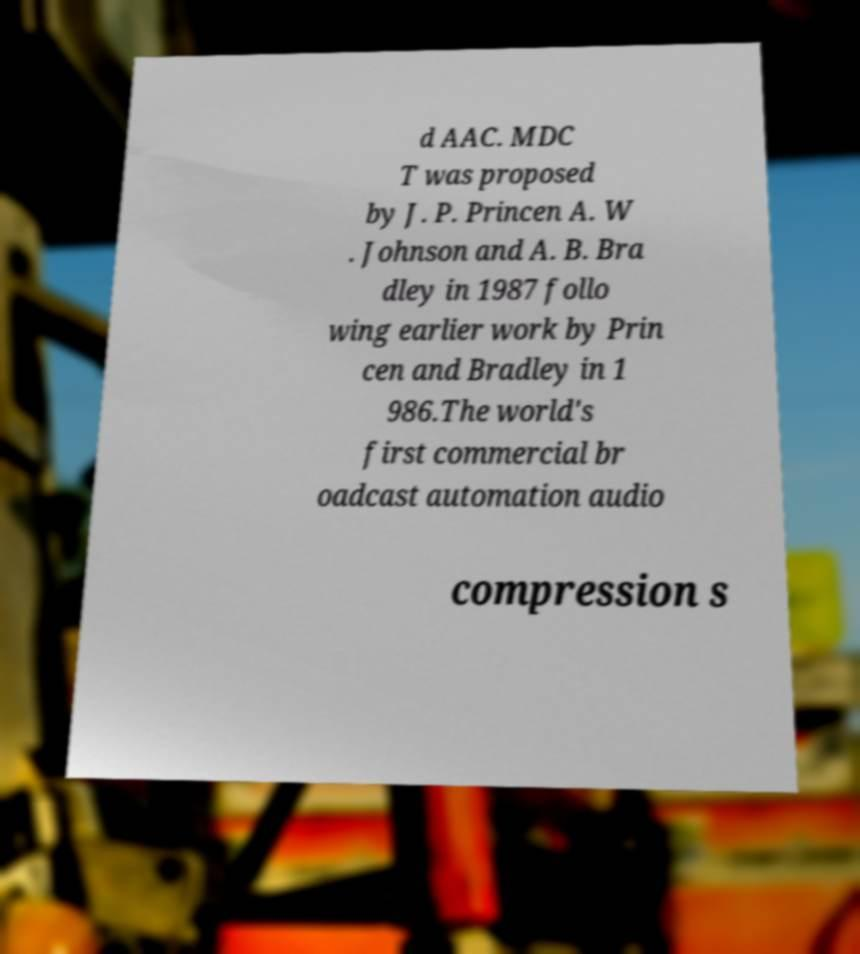Could you assist in decoding the text presented in this image and type it out clearly? d AAC. MDC T was proposed by J. P. Princen A. W . Johnson and A. B. Bra dley in 1987 follo wing earlier work by Prin cen and Bradley in 1 986.The world's first commercial br oadcast automation audio compression s 